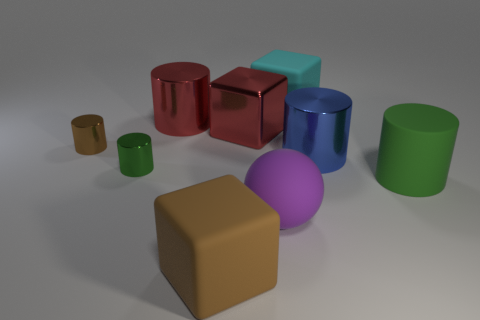Subtract all cylinders. How many objects are left? 4 Subtract 0 gray spheres. How many objects are left? 9 Subtract all cyan shiny spheres. Subtract all red cubes. How many objects are left? 8 Add 1 red shiny cubes. How many red shiny cubes are left? 2 Add 3 big red cylinders. How many big red cylinders exist? 4 